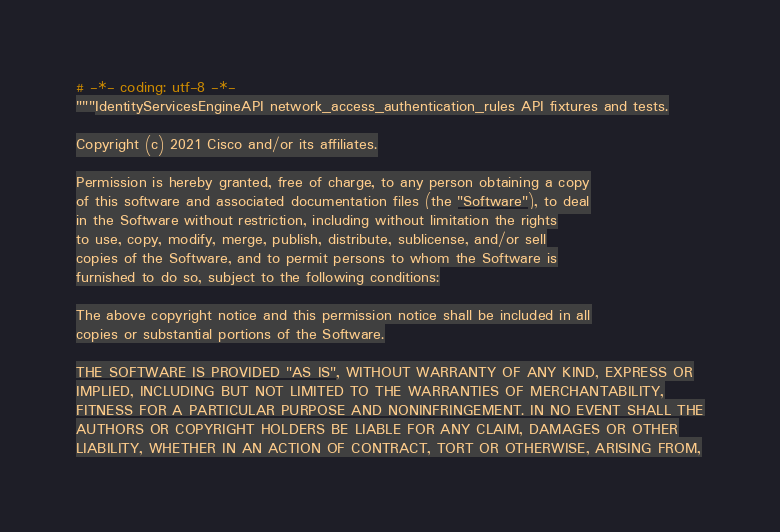<code> <loc_0><loc_0><loc_500><loc_500><_Python_># -*- coding: utf-8 -*-
"""IdentityServicesEngineAPI network_access_authentication_rules API fixtures and tests.

Copyright (c) 2021 Cisco and/or its affiliates.

Permission is hereby granted, free of charge, to any person obtaining a copy
of this software and associated documentation files (the "Software"), to deal
in the Software without restriction, including without limitation the rights
to use, copy, modify, merge, publish, distribute, sublicense, and/or sell
copies of the Software, and to permit persons to whom the Software is
furnished to do so, subject to the following conditions:

The above copyright notice and this permission notice shall be included in all
copies or substantial portions of the Software.

THE SOFTWARE IS PROVIDED "AS IS", WITHOUT WARRANTY OF ANY KIND, EXPRESS OR
IMPLIED, INCLUDING BUT NOT LIMITED TO THE WARRANTIES OF MERCHANTABILITY,
FITNESS FOR A PARTICULAR PURPOSE AND NONINFRINGEMENT. IN NO EVENT SHALL THE
AUTHORS OR COPYRIGHT HOLDERS BE LIABLE FOR ANY CLAIM, DAMAGES OR OTHER
LIABILITY, WHETHER IN AN ACTION OF CONTRACT, TORT OR OTHERWISE, ARISING FROM,</code> 